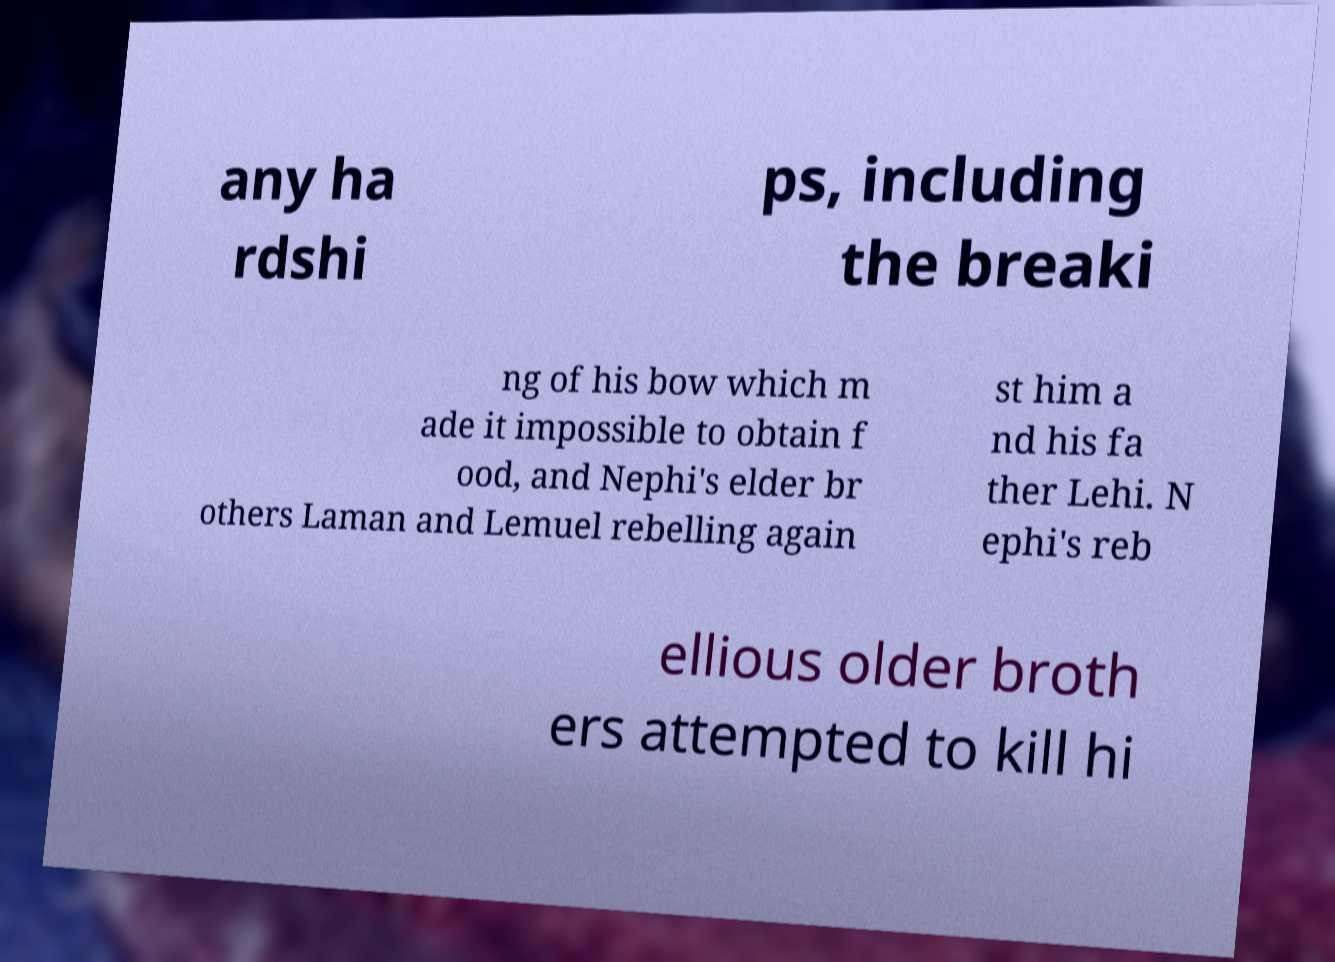Can you read and provide the text displayed in the image?This photo seems to have some interesting text. Can you extract and type it out for me? any ha rdshi ps, including the breaki ng of his bow which m ade it impossible to obtain f ood, and Nephi's elder br others Laman and Lemuel rebelling again st him a nd his fa ther Lehi. N ephi's reb ellious older broth ers attempted to kill hi 